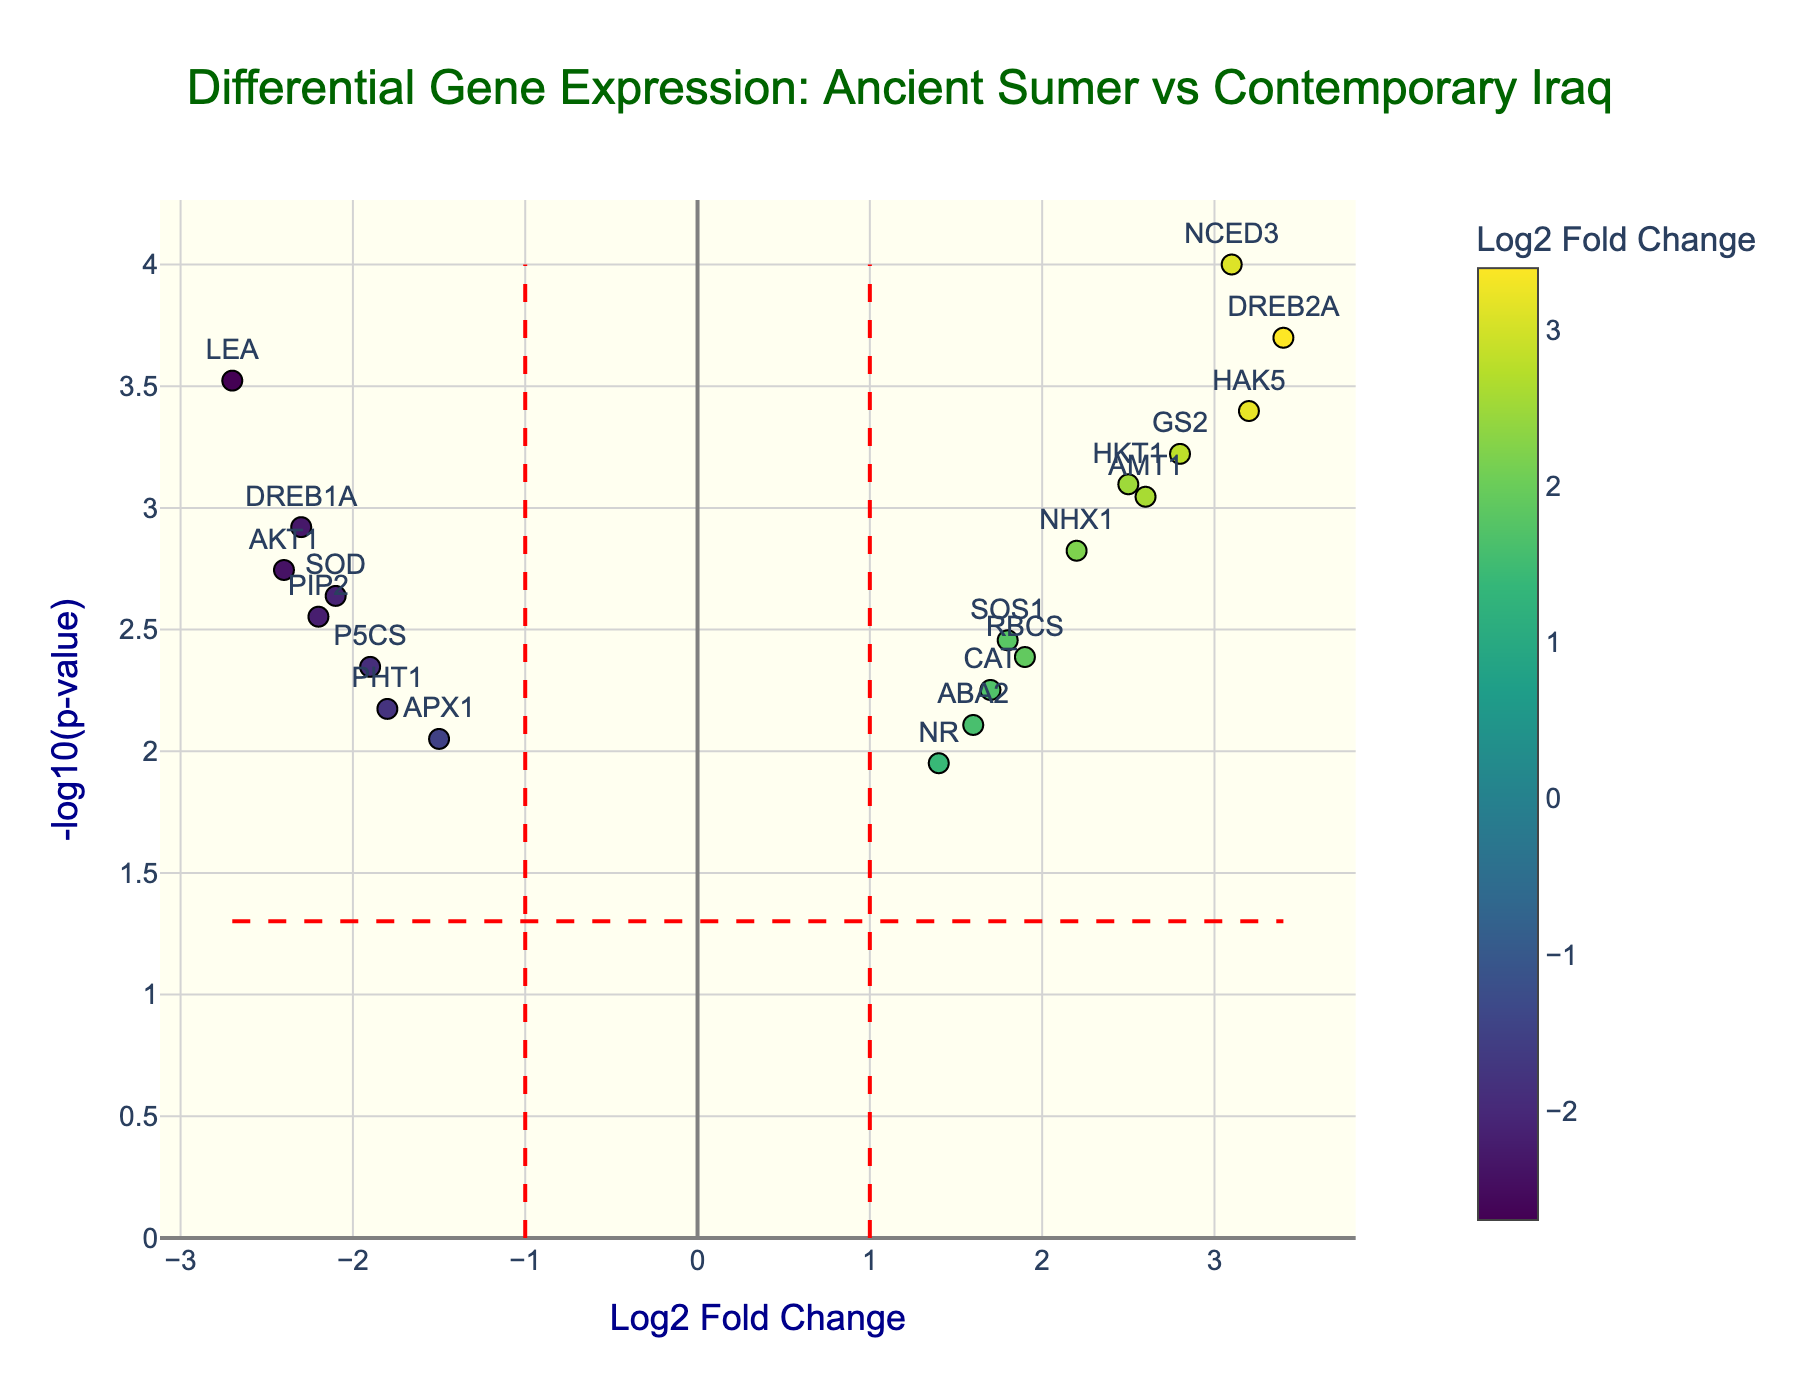Which gene has the highest -log10(p-value)? To determine the gene with the highest -log10(p-value), we look for the data point located at the top of the y-axis. The highest -log10(p-value) corresponds to the gene NCED3.
Answer: NCED3 What is the Log2 Fold Change value for the gene HKT1? Find the marker labeled HKT1 and check its position on the x-axis. The log2 fold change for HKT1 is 2.5.
Answer: 2.5 How many genes have a positive Log2 Fold Change? Count the number of points that are positioned to the right of the vertical line at x = 0. There are 9 such points.
Answer: 9 Which gene is closest to the vertical line at Log2 Fold Change = 1? Identify the data point nearest the vertical dashed red line located at x = 1. The gene RBCS, with a log2 fold change of 1.9, is closest.
Answer: RBCS Which gene exhibits the most significant downregulation (i.e., highest negative Log2 Fold Change)? Check for the gene with the most extreme negative x-axis value. The gene LEA, with a log2 fold change of -2.7, shows the most significant downregulation.
Answer: LEA How many genes have a p-value less than 0.05? Any data point above the horizontal dashed red line corresponds to a p-value less than 0.05. Count all such points. There are 15 such points.
Answer: 15 What is the Log2 Fold Change for the gene DREB2A? Locate the marker labeled DREB2A and note its x-axis position. The log2 fold change for DREB2A is 3.4.
Answer: 3.4 Compare the expression levels of genes ABA2 and AMT1 by their Log2 Fold Changes. Which one has a greater extent of upregulation? Compare the x-axis positions of ABA2 and AMT1. ABA2 has a log2 fold change of 1.6, while AMT1 has a log2 fold change of 2.6. AMT1 has a greater extent of upregulation.
Answer: AMT1 Identify the gene with the second highest -log10(p-value). The gene with the second highest -log10(p-value) is directly below NCED3 on the y-axis. It is DREB2A.
Answer: DREB2A Determine the total number of upregulated genes with a log2 fold change greater than 2. Count the number of points to the right of the vertical line at Log2 Fold Change = 2. There are 6 such points: NCED3, DREB2A, HKT1, NHX1, GS2, HAK5.
Answer: 6 